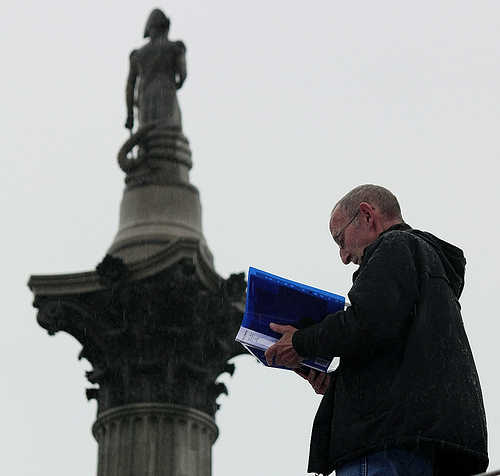<image>
Is there a book on the man? No. The book is not positioned on the man. They may be near each other, but the book is not supported by or resting on top of the man. 